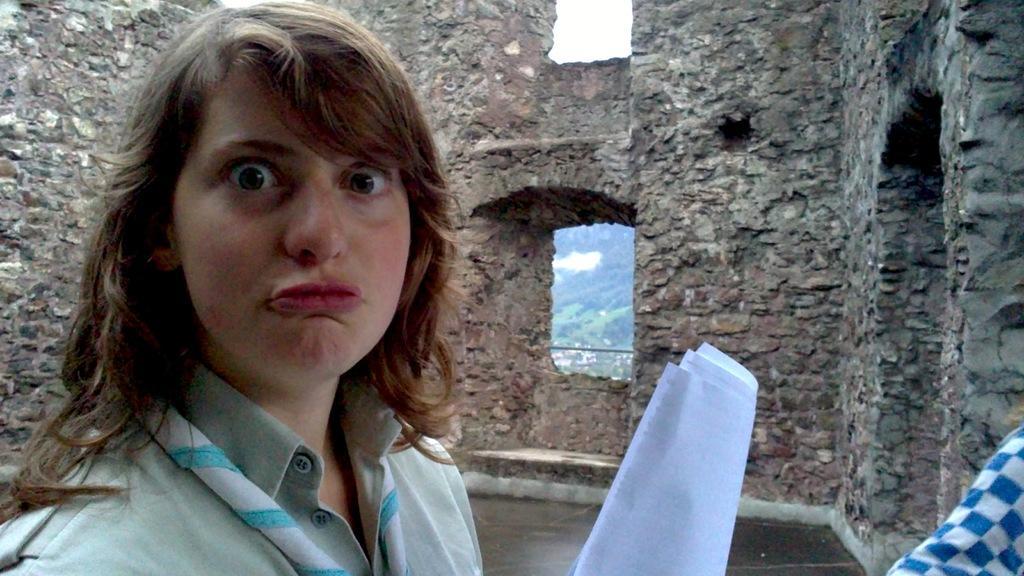Can you describe this image briefly? In this image we can see a lady making a different facial expression and she is wearing a green color dress and holding some papers in her hand. 